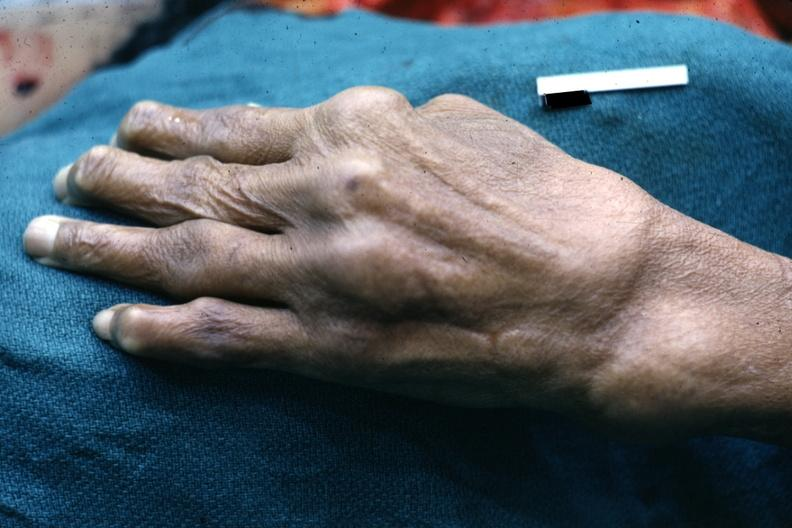re extremities present?
Answer the question using a single word or phrase. Yes 